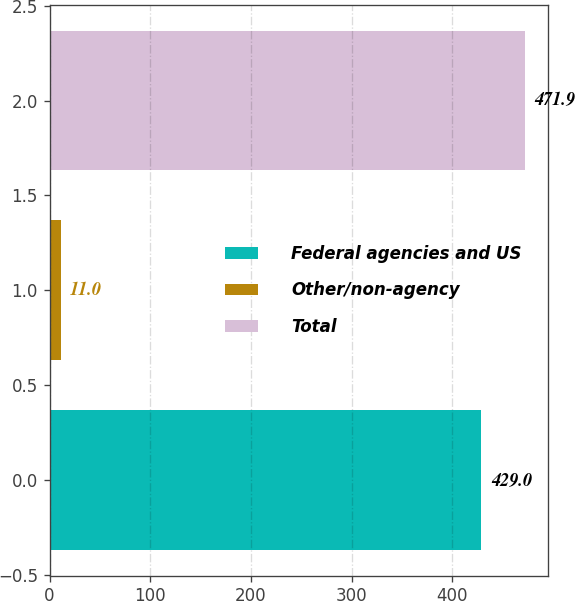Convert chart to OTSL. <chart><loc_0><loc_0><loc_500><loc_500><bar_chart><fcel>Federal agencies and US<fcel>Other/non-agency<fcel>Total<nl><fcel>429<fcel>11<fcel>471.9<nl></chart> 